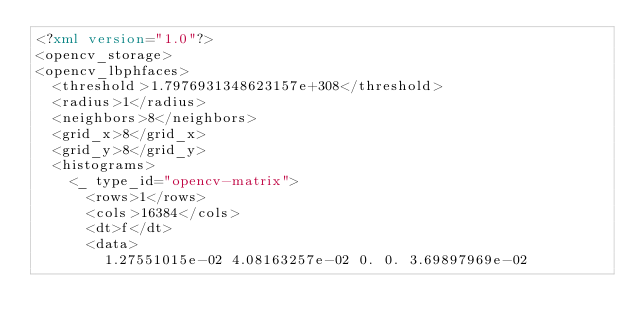Convert code to text. <code><loc_0><loc_0><loc_500><loc_500><_XML_><?xml version="1.0"?>
<opencv_storage>
<opencv_lbphfaces>
  <threshold>1.7976931348623157e+308</threshold>
  <radius>1</radius>
  <neighbors>8</neighbors>
  <grid_x>8</grid_x>
  <grid_y>8</grid_y>
  <histograms>
    <_ type_id="opencv-matrix">
      <rows>1</rows>
      <cols>16384</cols>
      <dt>f</dt>
      <data>
        1.27551015e-02 4.08163257e-02 0. 0. 3.69897969e-02</code> 